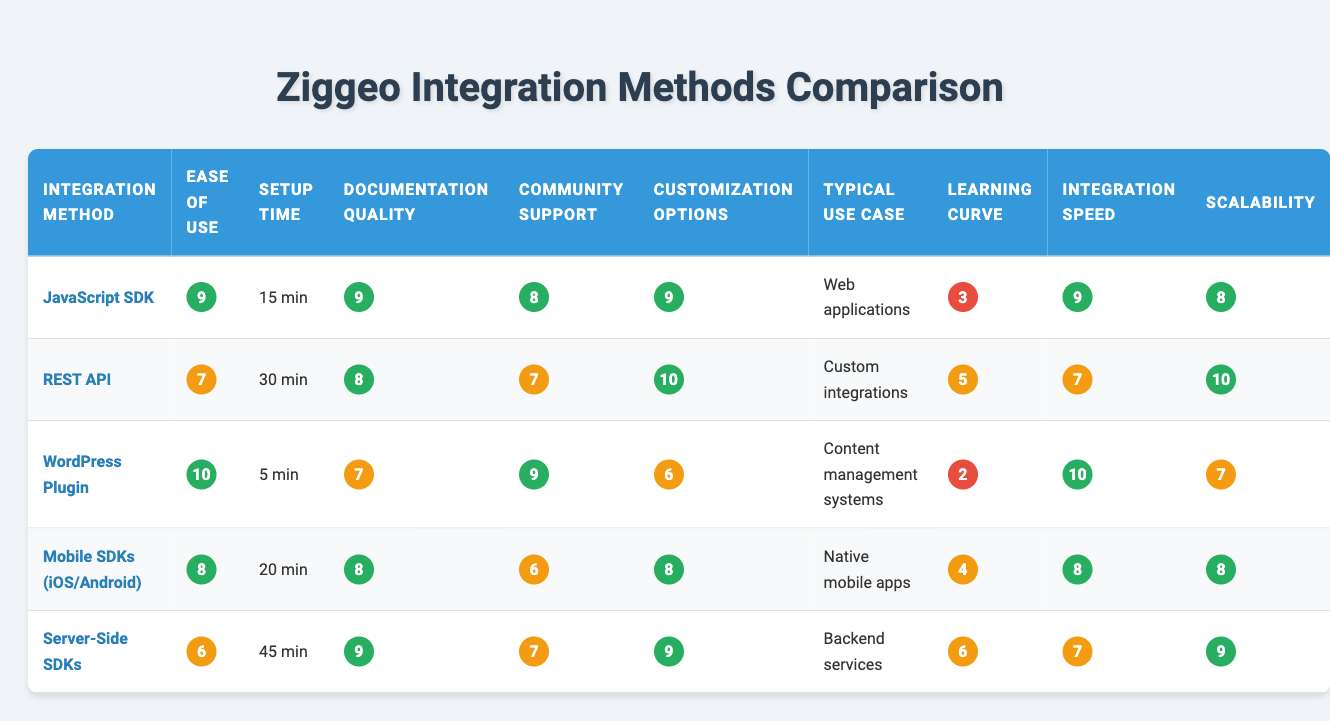What is the ease of use rating for the WordPress Plugin? The table shows that the ease of use rating for the WordPress Plugin is 10.
Answer: 10 What integration method has the highest documentation quality? The JavaScript SDK and Server-Side SDKs both have a documentation quality rating of 9, which is the highest in the table.
Answer: JavaScript SDK and Server-Side SDKs Which integration method has the longest setup time? The table indicates that the Server-Side SDKs have the longest setup time of 45 minutes.
Answer: 45 minutes What is the average customization options rating for all integration methods? To find the average, sum the customization ratings (9 + 10 + 6 + 8 + 9 = 42) and divide by the number of methods (5): 42 / 5 = 8.4.
Answer: 8.4 Does the Mobile SDKs have a higher ease of use rating than the Server-Side SDKs? The Mobile SDKs have an ease of use rating of 8, while the Server-Side SDKs have a rating of 6, thus it is true that Mobile SDKs are rated higher.
Answer: Yes How do the Learning Curve ratings compare between the WordPress Plugin and the REST API? The WordPress Plugin has a learning curve rating of 2, while the REST API has a rating of 5. Since 2 is less than 5, the WordPress Plugin has an easier learning curve.
Answer: WordPress Plugin has a lower rating What is the difference in integration speed ratings between the REST API and the JavaScript SDK? The REST API has a rating of 7, and the JavaScript SDK has a rating of 9. The difference is 9 - 7 = 2.
Answer: 2 Identify the integration method with the lowest community support rating. The table shows the Mobile SDKs have the lowest community support rating of 6.
Answer: Mobile SDKs Which integration method has the best combination of high ease of use and low setup time? The minimal setup time and high ease of use ratings indicate that the WordPress Plugin with a rating of 10 and a setup time of 5 minutes offers the best combination.
Answer: WordPress Plugin What method is preferred for native mobile apps? According to the typical use case column, the preferred method for native mobile apps is the Mobile SDKs (iOS/Android).
Answer: Mobile SDKs (iOS/Android) 